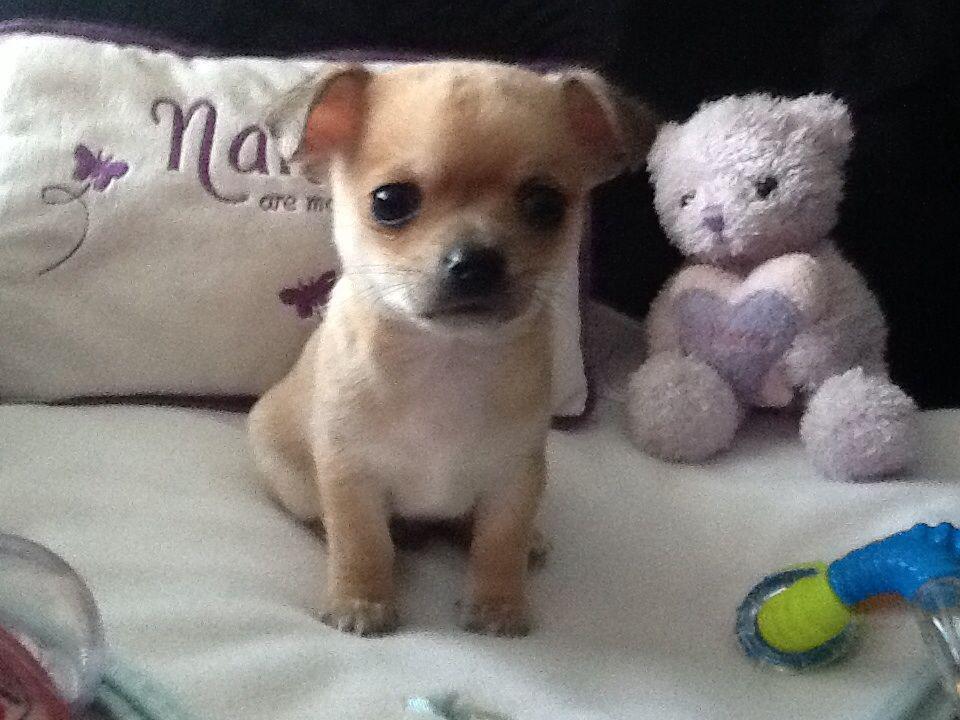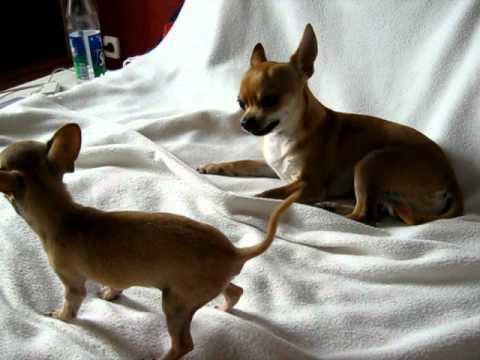The first image is the image on the left, the second image is the image on the right. For the images displayed, is the sentence "At least one image shows two similarly colored chihuahuas." factually correct? Answer yes or no. Yes. The first image is the image on the left, the second image is the image on the right. Examine the images to the left and right. Is the description "Atleast one image contains both a brown and white chihuahua." accurate? Answer yes or no. No. 